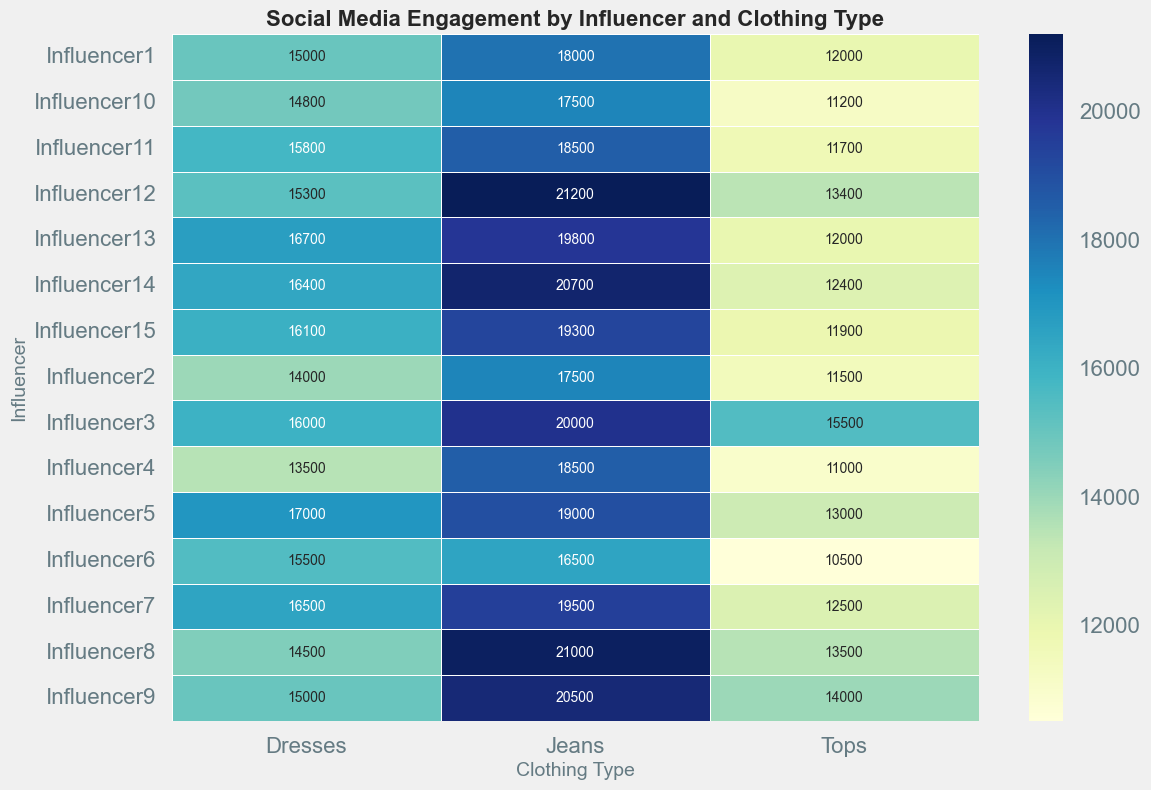Which influencer has the highest social media engagement for Dresses? Look at the heatmap and find the cell in the "Dresses" column with the highest value.
Answer: Influencer5 Which clothing type does Influencer10 have the lowest engagement for? Identify the minimum value among the cells corresponding to Influencer10 across all clothing types.
Answer: Tops What is the total engagement for Influencer3 across all clothing types? Sum up the values for Dresses, Tops, and Jeans corresponding to Influencer3. 16000 (Dresses) + 15500 (Tops) + 20000 (Jeans) = 51500
Answer: 51500 Which clothing type has the highest average engagement across all influencers? Calculate the average engagement for Dresses, Tops, and Jeans by summing the values in each column and dividing by the number of influencers (15). Then compare these averages.
Answer: Jeans Is there any influencer with equal engagement for two clothing types? Check the values across all rows to see if there are any repeating values within the same row. No influencer has identical values for two clothing types.
Answer: No What is the difference in engagement between Influencer7 and Influencer14 for Jeans? Subtract the engagement value of Jeans for Influencer14 from that of Influencer7. 19500 (Influencer7) - 20700 (Influencer14) = -1200
Answer: -1200 Which influencer had higher engagement for Tops: Influencer8 or Influencer13? Compare the engagement values for Tops corresponding to Influencer8 and Influencer13. 13500 (Influencer8) vs. 12000 (Influencer13)
Answer: Influencer8 What is the color indicating highest engagement in the heatmap? Find the cell with the highest engagement value and note its color, typically in the heatmap's legend describing the color gradient.
Answer: Dark Green What’s the average engagement for Tops posted by Influencer5 and Influencer6 together? Sum the engagement values for Tops for Influencer5 and Influencer6, then divide by 2. (13000 + 10500) / 2 = 11750
Answer: 11750 Which influencer has the most balanced engagement across all clothing types, considering the least variance? Calculate the variance or range of engagement values for each influencer, then identify the influencer with the smallest difference between their maximum and minimum engagement values. Influencer5: 19000 - 13000 = 6000, Influencer6: 16500 - 10500 = 6000, etc. Influencer5's values are quite close and have one of the smallest differences.
Answer: Influencer5 